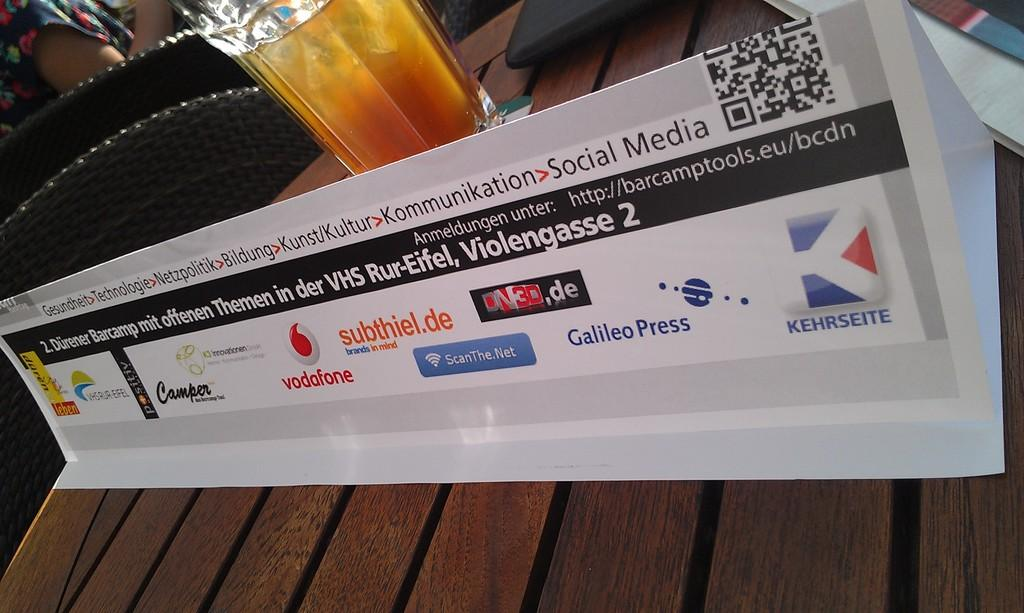<image>
Summarize the visual content of the image. A placard written mostly in German but including the term Social Media sits on a wooden table in front of a glass of beer. 